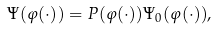Convert formula to latex. <formula><loc_0><loc_0><loc_500><loc_500>\Psi ( \varphi ( \cdot ) ) = P ( \varphi ( \cdot ) ) \Psi _ { 0 } ( \varphi ( \cdot ) ) ,</formula> 